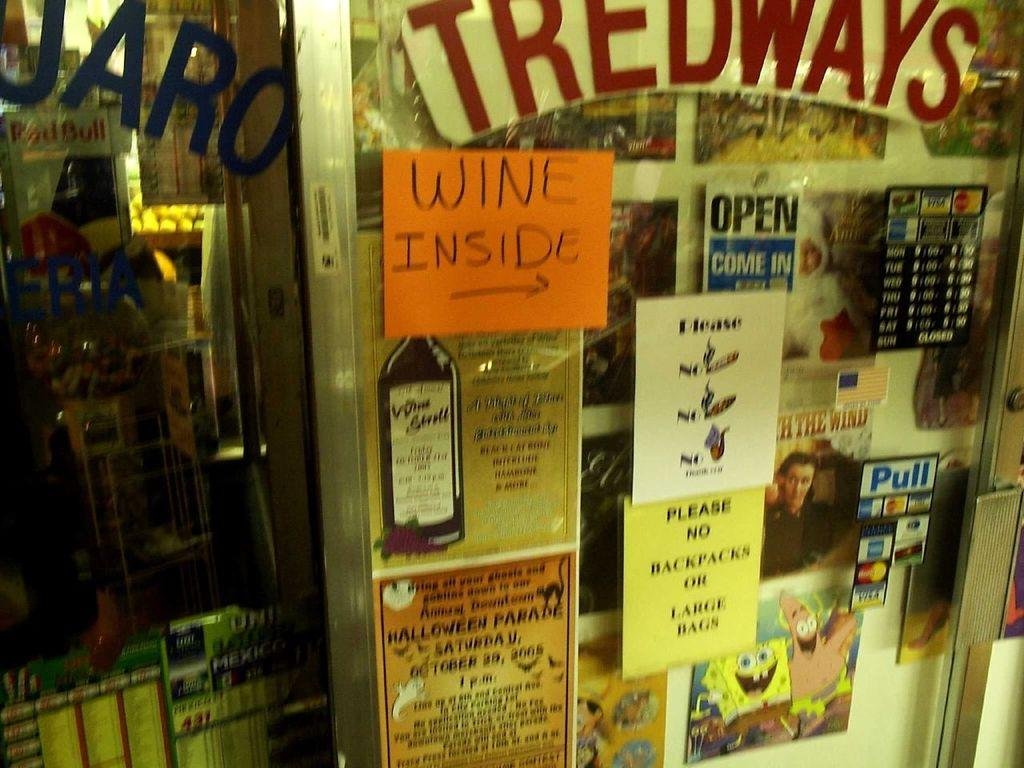<image>
Offer a succinct explanation of the picture presented. door for tredways showing store is open and that they have wine inside 